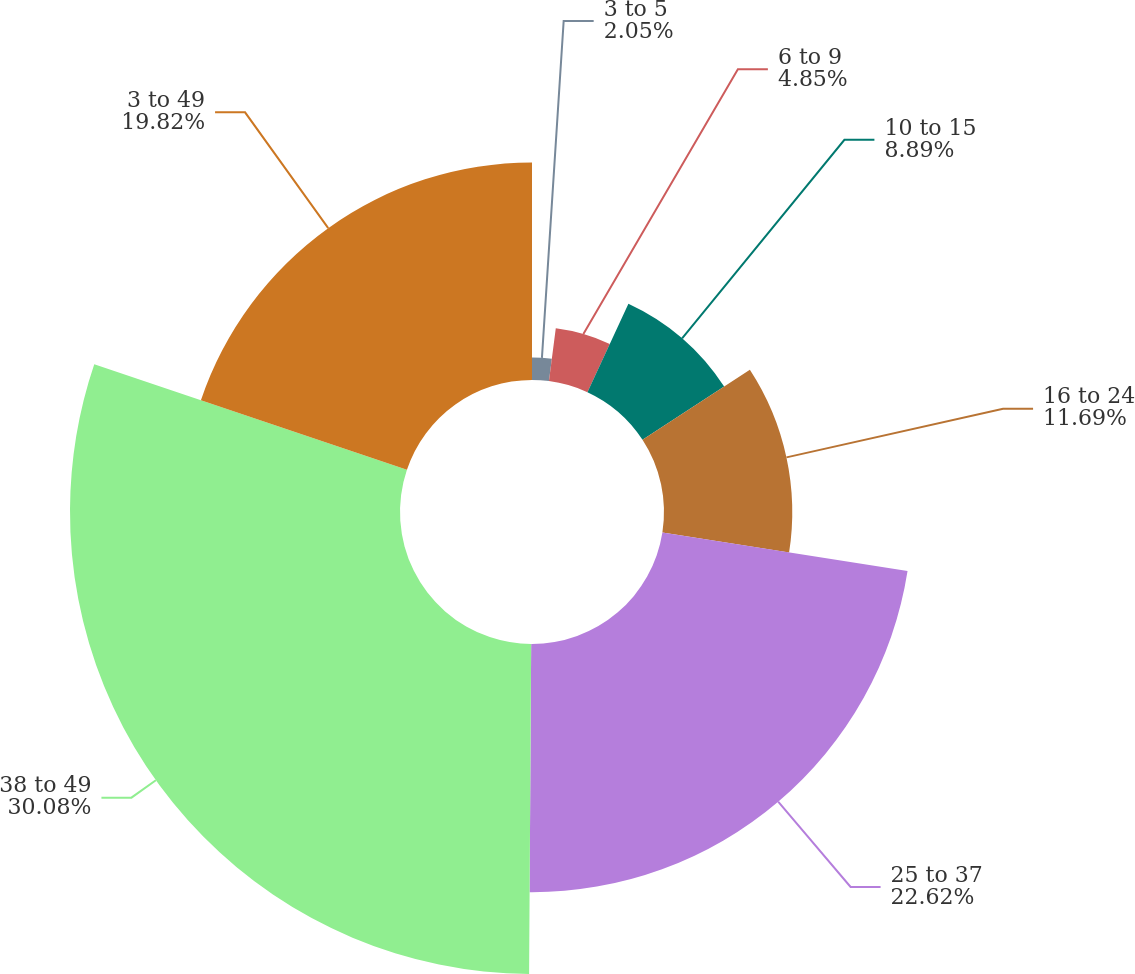<chart> <loc_0><loc_0><loc_500><loc_500><pie_chart><fcel>3 to 5<fcel>6 to 9<fcel>10 to 15<fcel>16 to 24<fcel>25 to 37<fcel>38 to 49<fcel>3 to 49<nl><fcel>2.05%<fcel>4.85%<fcel>8.89%<fcel>11.69%<fcel>22.62%<fcel>30.08%<fcel>19.82%<nl></chart> 